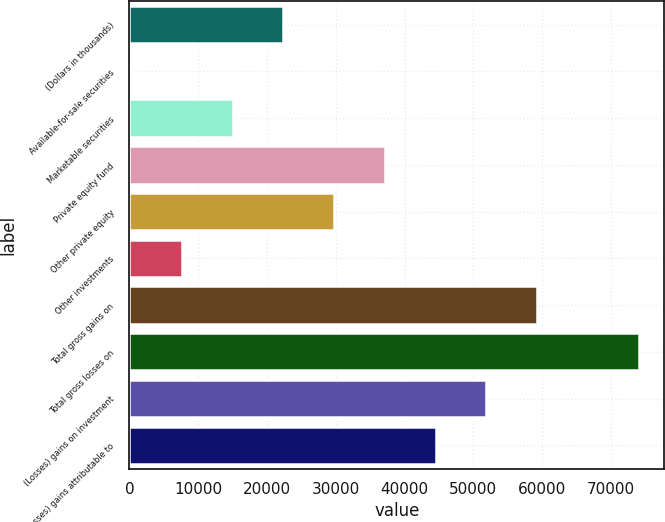<chart> <loc_0><loc_0><loc_500><loc_500><bar_chart><fcel>(Dollars in thousands)<fcel>Available-for-sale securities<fcel>Marketable securities<fcel>Private equity fund<fcel>Other private equity<fcel>Other investments<fcel>Total gross gains on<fcel>Total gross losses on<fcel>(Losses) gains on investment<fcel>(Losses) gains attributable to<nl><fcel>22379.7<fcel>246<fcel>15001.8<fcel>37135.5<fcel>29757.6<fcel>7623.9<fcel>59269.2<fcel>74025<fcel>51891.3<fcel>44513.4<nl></chart> 